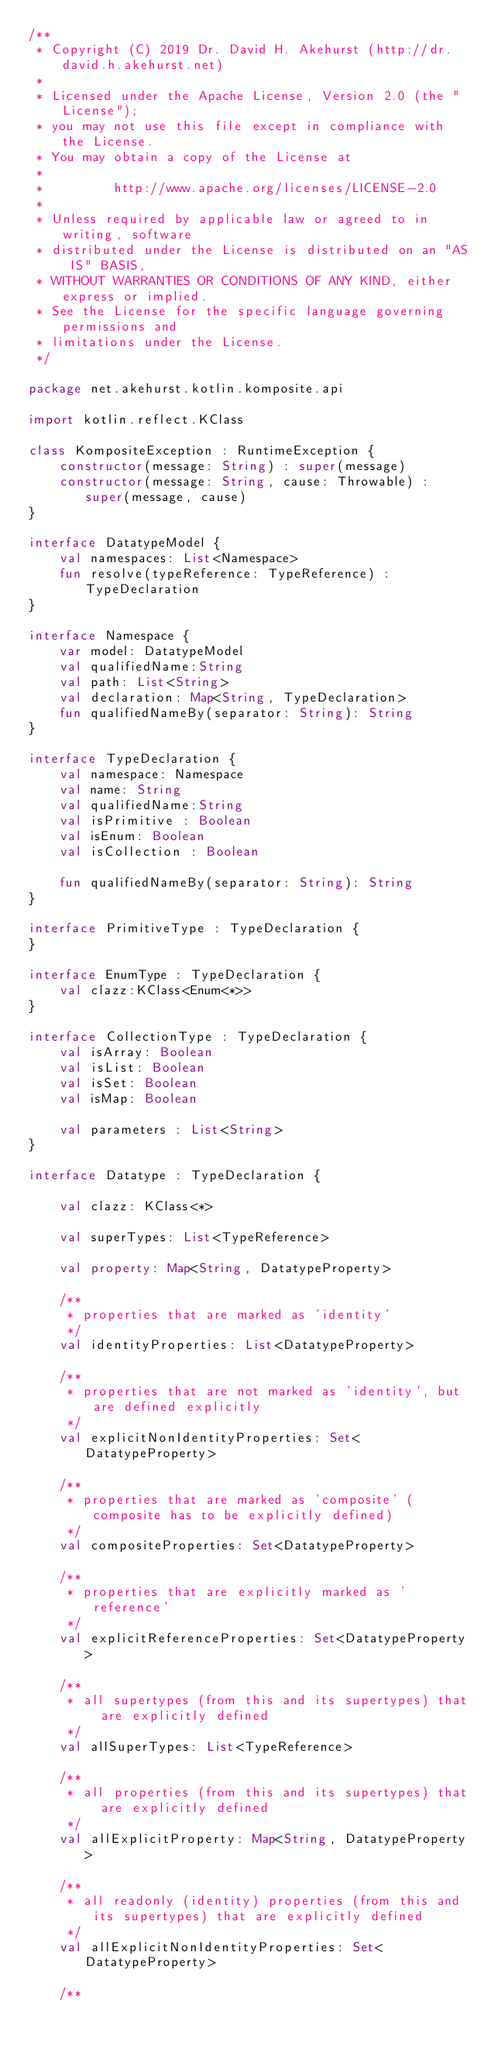Convert code to text. <code><loc_0><loc_0><loc_500><loc_500><_Kotlin_>/**
 * Copyright (C) 2019 Dr. David H. Akehurst (http://dr.david.h.akehurst.net)
 *
 * Licensed under the Apache License, Version 2.0 (the "License");
 * you may not use this file except in compliance with the License.
 * You may obtain a copy of the License at
 *
 *         http://www.apache.org/licenses/LICENSE-2.0
 *
 * Unless required by applicable law or agreed to in writing, software
 * distributed under the License is distributed on an "AS IS" BASIS,
 * WITHOUT WARRANTIES OR CONDITIONS OF ANY KIND, either express or implied.
 * See the License for the specific language governing permissions and
 * limitations under the License.
 */

package net.akehurst.kotlin.komposite.api

import kotlin.reflect.KClass

class KompositeException : RuntimeException {
    constructor(message: String) : super(message)
    constructor(message: String, cause: Throwable) : super(message, cause)
}

interface DatatypeModel {
    val namespaces: List<Namespace>
    fun resolve(typeReference: TypeReference) : TypeDeclaration
}

interface Namespace {
    var model: DatatypeModel
    val qualifiedName:String
    val path: List<String>
    val declaration: Map<String, TypeDeclaration>
    fun qualifiedNameBy(separator: String): String
}

interface TypeDeclaration {
    val namespace: Namespace
    val name: String
    val qualifiedName:String
    val isPrimitive : Boolean
    val isEnum: Boolean
    val isCollection : Boolean

    fun qualifiedNameBy(separator: String): String
}

interface PrimitiveType : TypeDeclaration {
}

interface EnumType : TypeDeclaration {
    val clazz:KClass<Enum<*>>
}

interface CollectionType : TypeDeclaration {
    val isArray: Boolean
    val isList: Boolean
    val isSet: Boolean
    val isMap: Boolean

    val parameters : List<String>
}

interface Datatype : TypeDeclaration {

    val clazz: KClass<*>

    val superTypes: List<TypeReference>

    val property: Map<String, DatatypeProperty>

    /**
     * properties that are marked as 'identity'
     */
    val identityProperties: List<DatatypeProperty>

    /**
     * properties that are not marked as 'identity', but are defined explicitly
     */
    val explicitNonIdentityProperties: Set<DatatypeProperty>

    /**
     * properties that are marked as 'composite' (composite has to be explicitly defined)
     */
    val compositeProperties: Set<DatatypeProperty>

    /**
     * properties that are explicitly marked as 'reference'
     */
    val explicitReferenceProperties: Set<DatatypeProperty>

    /**
     * all supertypes (from this and its supertypes) that are explicitly defined
     */
    val allSuperTypes: List<TypeReference>

    /**
     * all properties (from this and its supertypes) that are explicitly defined
     */
    val allExplicitProperty: Map<String, DatatypeProperty>

    /**
     * all readonly (identity) properties (from this and its supertypes) that are explicitly defined
     */
    val allExplicitNonIdentityProperties: Set<DatatypeProperty>

    /**</code> 